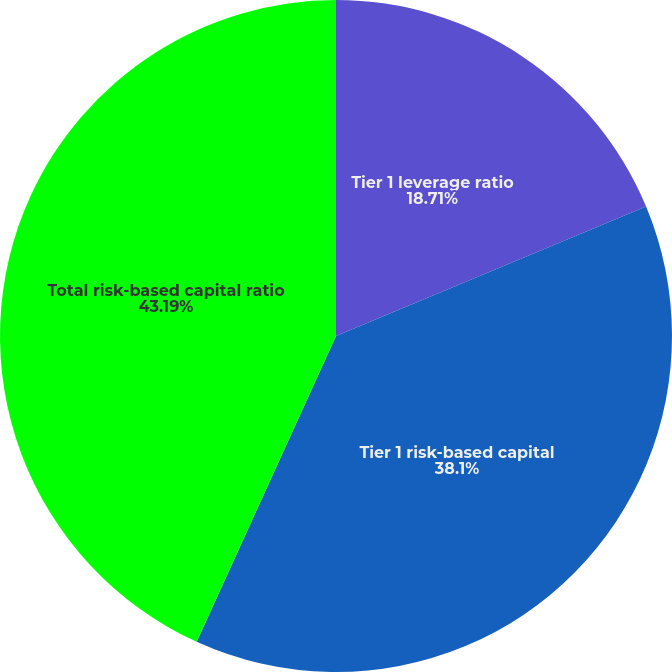<chart> <loc_0><loc_0><loc_500><loc_500><pie_chart><fcel>Tier 1 leverage ratio<fcel>Tier 1 risk-based capital<fcel>Total risk-based capital ratio<nl><fcel>18.71%<fcel>38.1%<fcel>43.2%<nl></chart> 